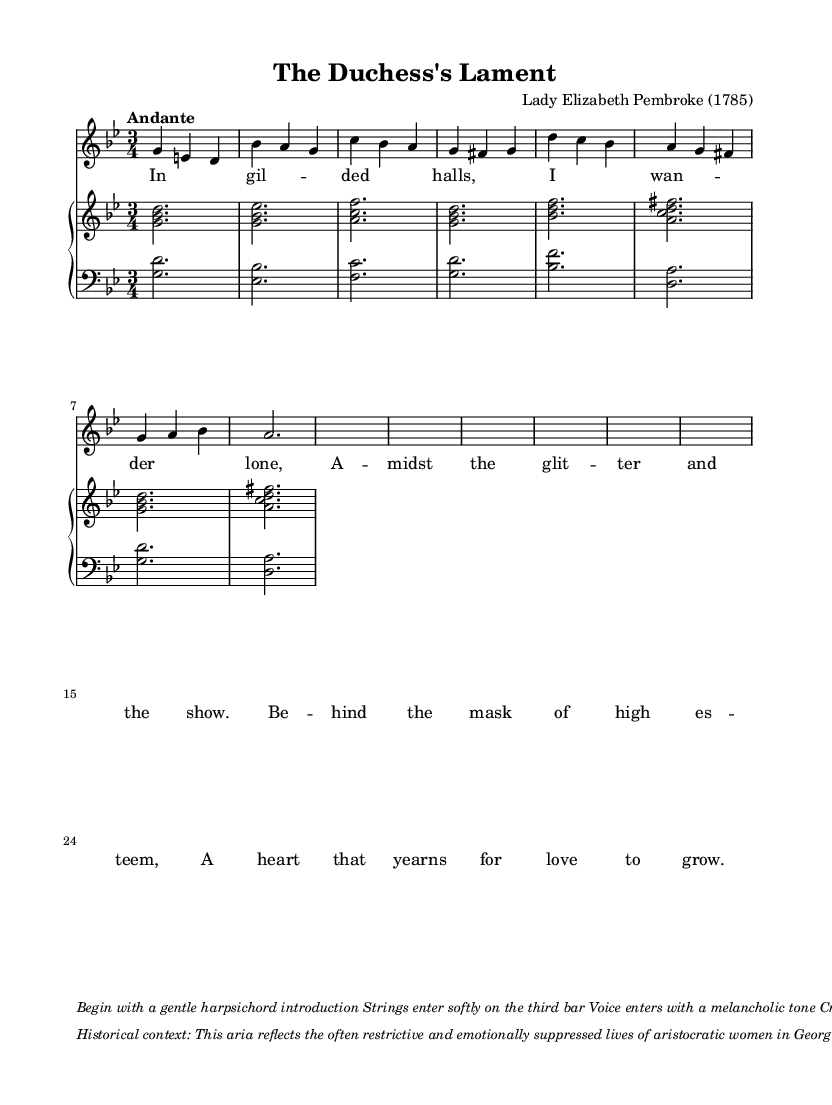What is the key signature of this music? The key signature is indicated at the beginning of the staff, and it has two flats, which corresponds to G minor.
Answer: G minor What is the time signature of this piece? The time signature is shown at the beginning of the score as 3/4, which means there are three beats per measure, and the quarter note receives one beat.
Answer: 3/4 What is the tempo marking of this aria? The tempo is noted in the score as "Andante", which refers to a moderate walking pace.
Answer: Andante How many measures are in the soprano part? The soprano part's measures can be counted visually within the staff; there are eight measures.
Answer: Eight What is the first note of the soprano part? The first note in the soprano part is g, which is located on the second line of the treble staff.
Answer: g What emotional theme does this aria express? The lyrics suggest a theme of longing and emotional suppression in high society, particularly for aristocratic women.
Answer: Longing What is the final dynamic marking in the score? The score indicates a diminuendo at the end, suggesting a gradual decrease in volume as it concludes.
Answer: Diminuendo 